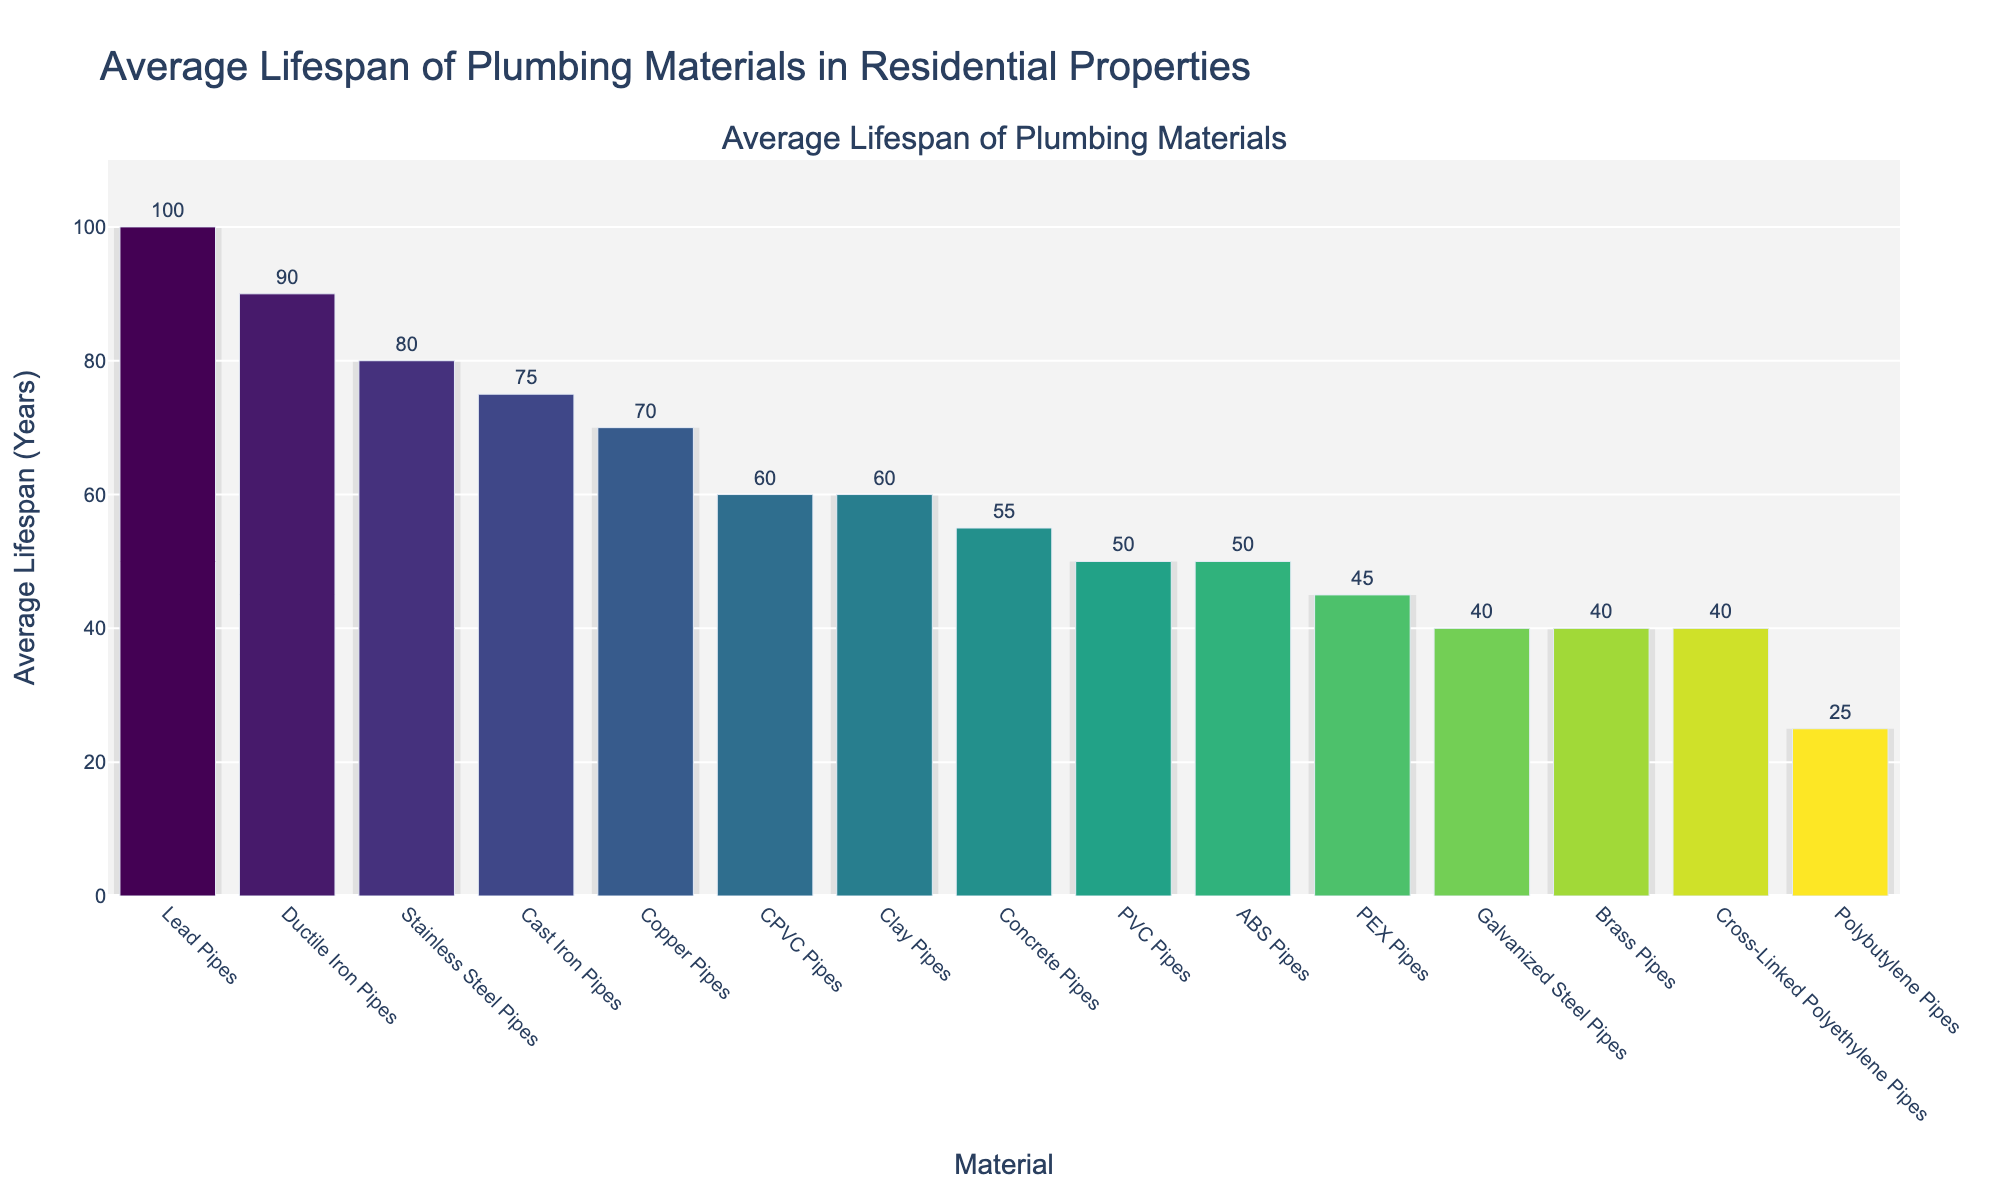Which material has the longest average lifespan? The bar chart shows various materials and their respective average lifespans. The tallest bar represents the material with the longest lifespan.
Answer: Lead Pipes Which material has the shortest average lifespan? The bar chart shows various materials and their respective lifespans. The shortest bar represents the material with the shortest lifespan.
Answer: Polybutylene Pipes What is the difference in average lifespan between Copper Pipes and PEX Pipes? Locate the bars for Copper Pipes and PEX Pipes. Copper Pipes have an average lifespan of 70 years, and PEX Pipes have an average lifespan of 45 years. The difference is 70 - 45.
Answer: 25 years How many materials have an average lifespan of 50 years? Identify the bars that indicate a 50-year lifespan. There are two materials with this lifespan: PVC Pipes and ABS Pipes.
Answer: 2 Which material has a noticeably darker bar and what is its average lifespan? Look for the bar with the darkest shade. The bar representing Lead Pipes is the darkest and thus has the highest lifespan of 100 years.
Answer: Lead Pipes, 100 years Which materials have a lifespan greater than 60 years but less than 80 years? Identify the bars whose lifespans fall between 60 and 80 years. These are Copper Pipes (70 years), CPVC Pipes (60 years), and Cast Iron Pipes (75 years).
Answer: Copper Pipes, CPVC Pipes, Cast Iron Pipes What's the combined lifespan of Brass Pipes and Cross-Linked Polyethylene Pipes? Locate the bars for Brass Pipes and Cross-Linked Polyethylene Pipes. Their lifespans are 40 years each. The combined lifespan is 40 + 40.
Answer: 80 years Are there more materials with a lifespan above or below 50 years? Count the number of materials above and below 50 years. There are 8 materials with a lifespan below 50 years and 7 materials above 50 years.
Answer: Below 50 years 